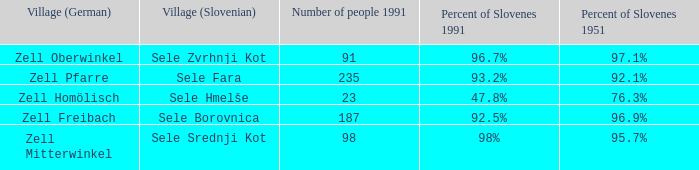Provide me with the name of all the village (German) that are part of the village (Slovenian) with sele srednji kot.  Zell Mitterwinkel. 